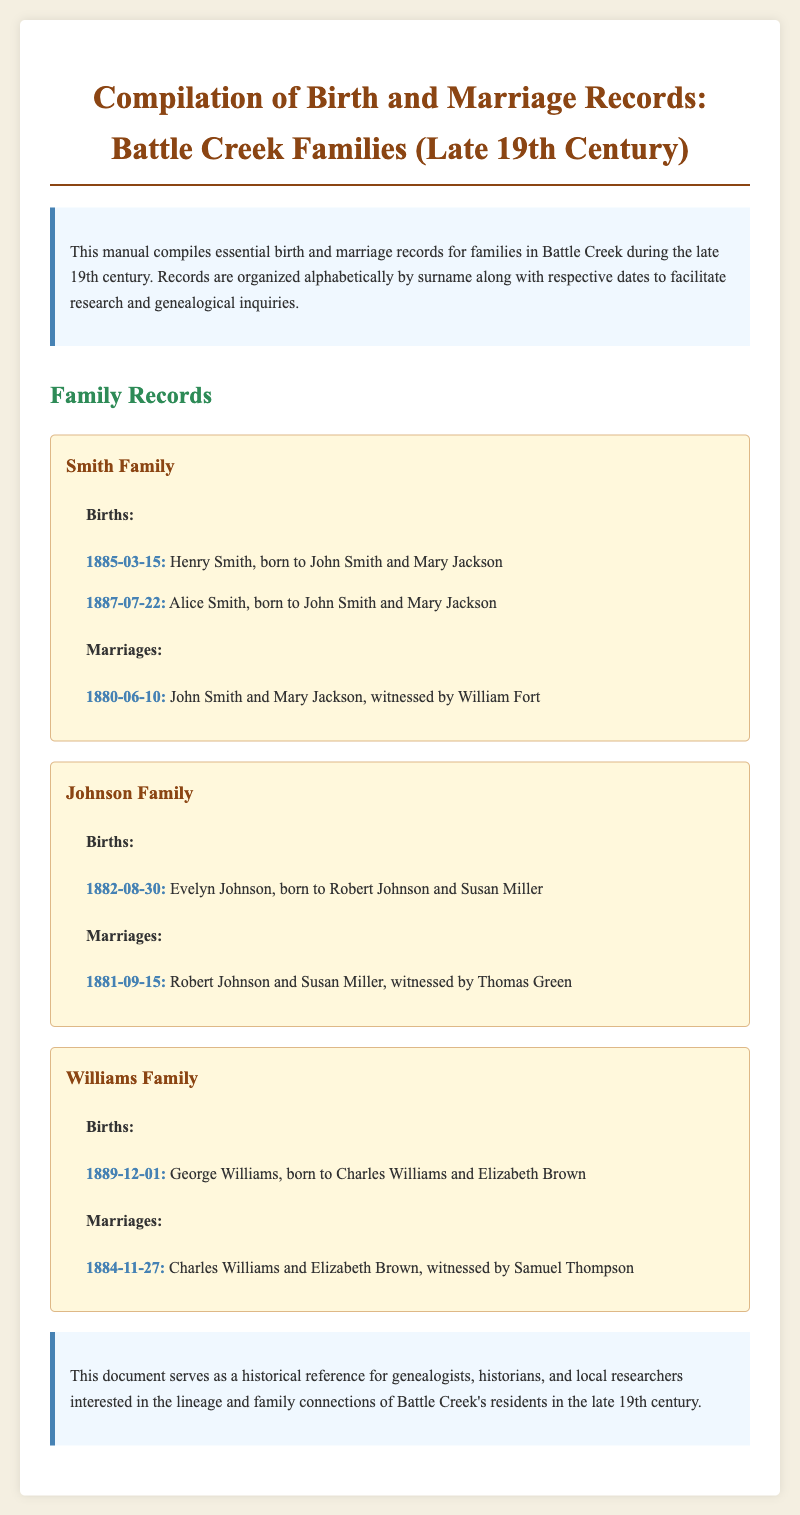What is the birth date of Henry Smith? The birth date for Henry Smith is provided under the Smith family records, which states he was born on 1885-03-15.
Answer: 1885-03-15 Who were the parents of Alice Smith? Alice Smith's birth record indicates her parents as John Smith and Mary Jackson in the Smith family section.
Answer: John Smith and Mary Jackson On what date did Robert Johnson marry Susan Miller? The marriage date of Robert Johnson and Susan Miller is mentioned as 1881-09-15 under the Johnson family records.
Answer: 1881-09-15 Which family does George Williams belong to? The document states George Williams's birth details under the Williams family records.
Answer: Williams Family What was the date of the marriage between Charles Williams and Elizabeth Brown? Their marriage is documented as occurring on 1884-11-27 according to the Williams family records.
Answer: 1884-11-27 How many children were listed in the Smith family records? The Smith family records list two births: Henry and Alice Smith, indicating the count is two.
Answer: Two Who witnessed the marriage of John Smith and Mary Jackson? The marriage record specifies that William Fort witnessed the marriage of John Smith and Mary Jackson.
Answer: William Fort What is the main purpose of this document? The manual serves as a historical reference for genealogists, historians, and local researchers.
Answer: Historical reference What is the style and background color used in the document? The document uses 'Bookman Old Style' and has a light beige background color (#f4efe1).
Answer: Light beige 